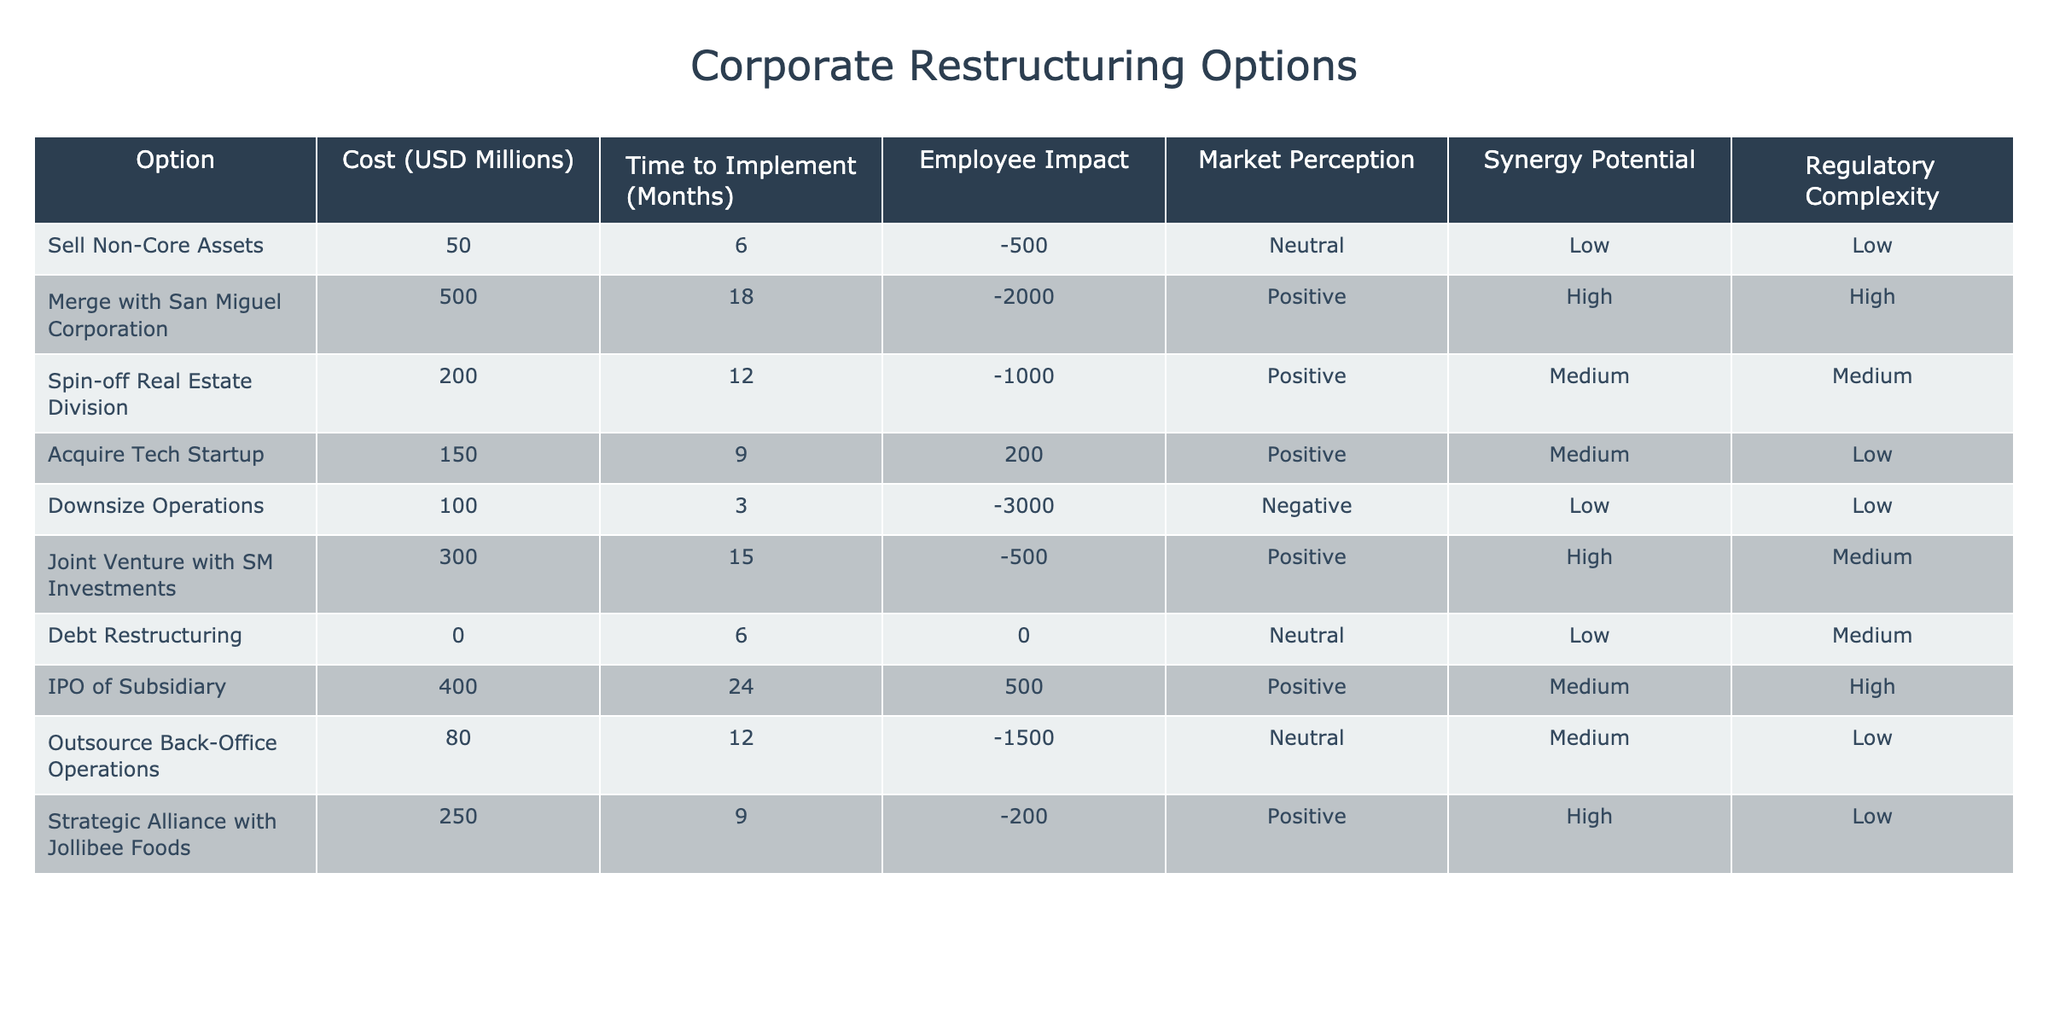What is the cost of downsizing operations? The table shows that the cost associated with downsizing operations is listed as 100 million USD under the 'Cost (USD Millions)' column.
Answer: 100 million USD Which option has the longest time to implement? Referring to the 'Time to Implement (Months)' column, the IPO of Subsidiary has the longest duration at 24 months.
Answer: 24 months How many employees would be affected if we spin off the real estate division? The table indicates that spinning off the real estate division would have a negative impact of 1000 employees as outlined in the 'Employee Impact' column.
Answer: -1000 Is the regulatory complexity high for merging with San Miguel Corporation? The data shows that the regulatory complexity for merging with San Miguel Corporation is classified as high in the 'Regulatory Complexity' column.
Answer: Yes What is the total cost of options that would negatively impact employees? We need to sum the costs of three options: downsizing operations (100 million USD), selling non-core assets (50 million USD), and outsourcing back-office operations (80 million USD). The total is 100 + 50 + 80 = 230 million USD.
Answer: 230 million USD Which option has the highest synergy potential? Reviewing the 'Synergy Potential' column, merging with San Miguel Corporation has the highest synergy potential marked as high, along with joint venture with SM Investments. However, merging with San Miguel Corporation is highlighted first in the table.
Answer: Merge with San Miguel Corporation What are the implications on market perception for outsourcing back-office operations? The table classifies the market perception impact of outsourcing back-office operations as neutral in the 'Market Perception' column.
Answer: Neutral What is the average time to implement among all options? To find the average, we first need to sum the implementation times: 6 + 18 + 12 + 9 + 3 + 15 + 6 + 24 + 12 + 9 =  114 months. Dividing by the number of options (10) gives us an average of 11.4 months.
Answer: 11.4 months 